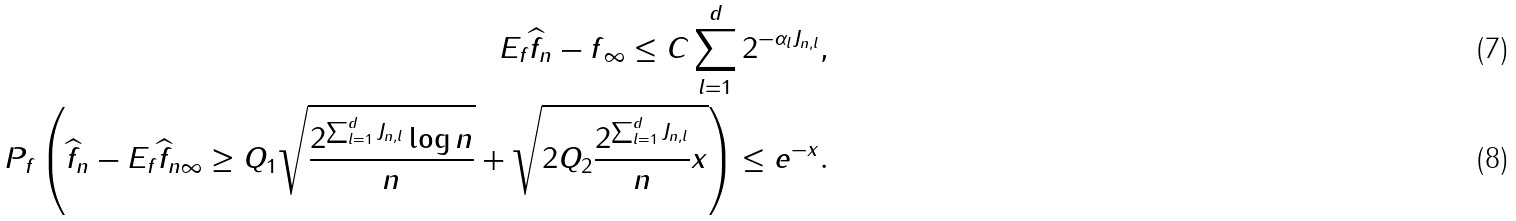<formula> <loc_0><loc_0><loc_500><loc_500>\| E _ { f } \widehat { f } _ { n } - f \| _ { \infty } \leq C \sum _ { l = 1 } ^ { d } 2 ^ { - \alpha _ { l } J _ { n , l } } , \\ P _ { f } \left ( \| \widehat { f } _ { n } - E _ { f } \widehat { f } _ { n } \| _ { \infty } \geq Q _ { 1 } \sqrt { \frac { 2 ^ { \sum _ { l = 1 } ^ { d } J _ { n , l } } \log { n } } { n } } + \sqrt { 2 Q _ { 2 } \frac { 2 ^ { \sum _ { l = 1 } ^ { d } J _ { n , l } } } { n } x } \right ) \leq e ^ { - x } .</formula> 